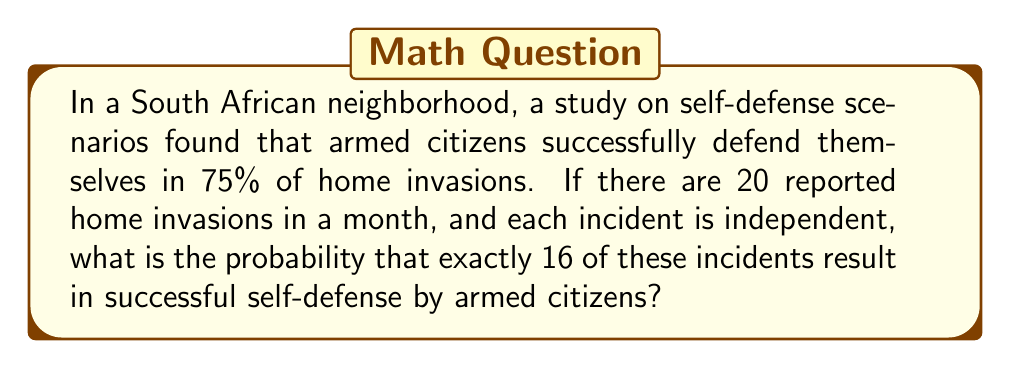What is the answer to this math problem? To solve this problem, we'll use the binomial probability distribution, as we have a fixed number of independent trials (home invasions) with two possible outcomes (successful or unsuccessful self-defense).

Let's define our variables:
$n = 20$ (number of home invasions)
$k = 16$ (number of successful self-defenses we're interested in)
$p = 0.75$ (probability of successful self-defense)

The binomial probability formula is:

$$P(X = k) = \binom{n}{k} p^k (1-p)^{n-k}$$

Where $\binom{n}{k}$ is the binomial coefficient, calculated as:

$$\binom{n}{k} = \frac{n!}{k!(n-k)!}$$

Step 1: Calculate the binomial coefficient
$$\binom{20}{16} = \frac{20!}{16!(20-16)!} = \frac{20!}{16!4!} = 4845$$

Step 2: Calculate $p^k$ and $(1-p)^{n-k}$
$p^k = 0.75^{16} = 0.0100$
$(1-p)^{n-k} = 0.25^4 = 0.0039$

Step 3: Apply the binomial probability formula
$$P(X = 16) = 4845 \times 0.0100 \times 0.0039 = 0.1886$$

Therefore, the probability of exactly 16 successful self-defenses out of 20 home invasions is approximately 0.1886 or 18.86%.
Answer: 0.1886 